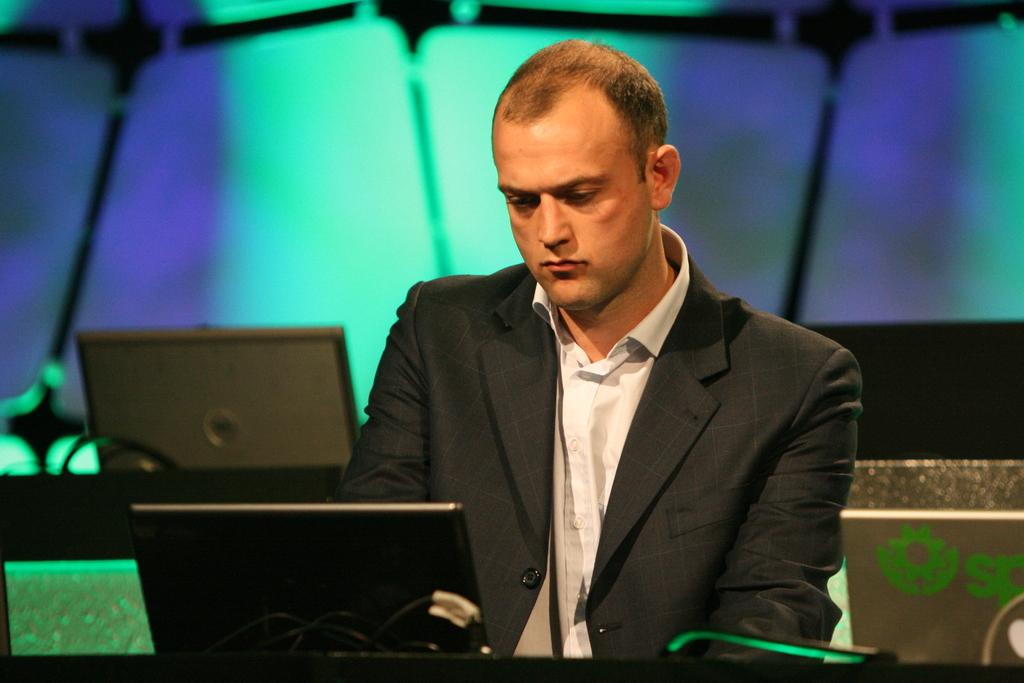What electronic devices are visible in the image? There are laptops in the image. Can you describe the person in the image? There is a person in the image, and they are wearing clothes. What can be said about the background of the image? The background of the image is blurred. How many boys are running on the trail in the image? There are no boys or trails present in the image; it features laptops and a person. 